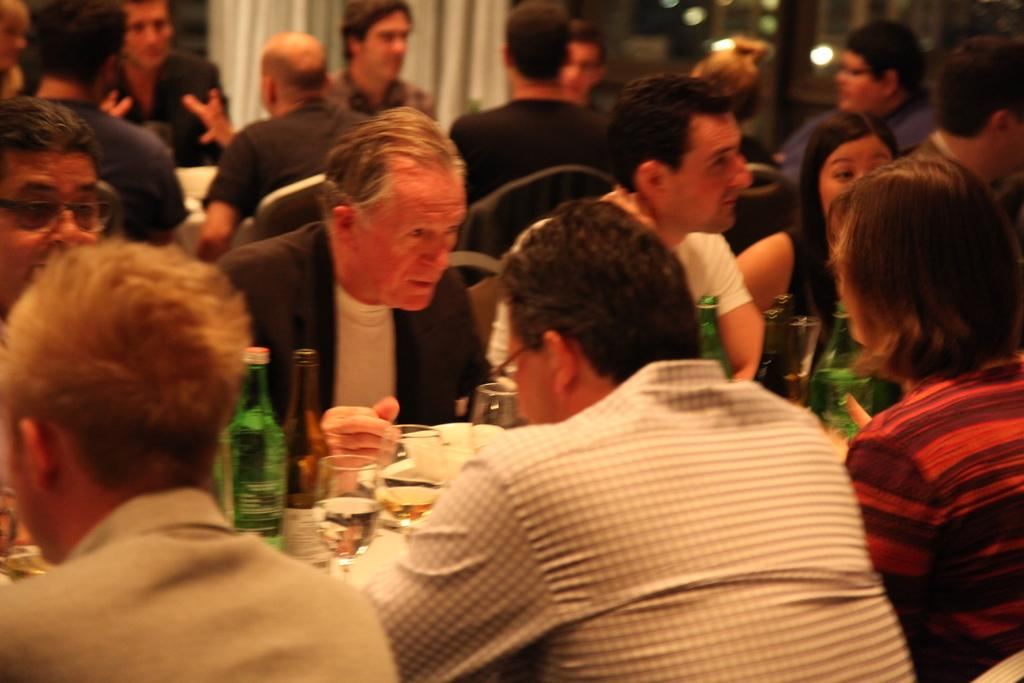What are the people in the image doing? The people in the image are sitting. What objects are present in the image that the people might be using? There are tables, bottles, glasses, plates, and food on the tables. Can you describe the items on the tables? Yes, there are bottles, glasses, plates, and food on the tables. What type of gold jewelry is the person wearing in the image? There is no gold jewelry visible in the image. Can you describe the rose on the table in the image? There is no rose present in the image. 